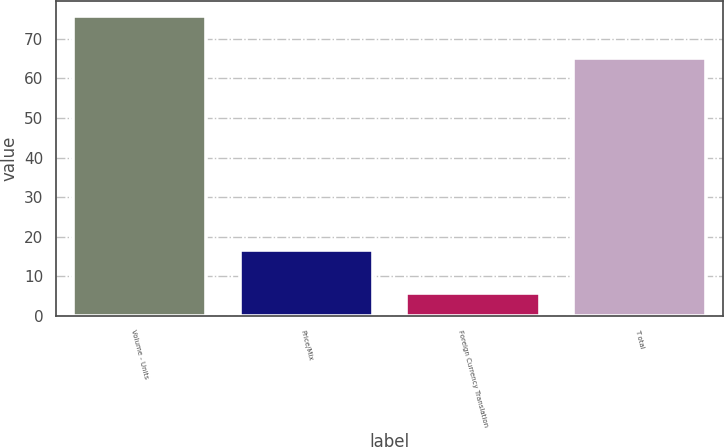Convert chart. <chart><loc_0><loc_0><loc_500><loc_500><bar_chart><fcel>Volume - Units<fcel>Price/Mix<fcel>Foreign Currency Translation<fcel>T otal<nl><fcel>75.8<fcel>16.6<fcel>5.9<fcel>65.1<nl></chart> 